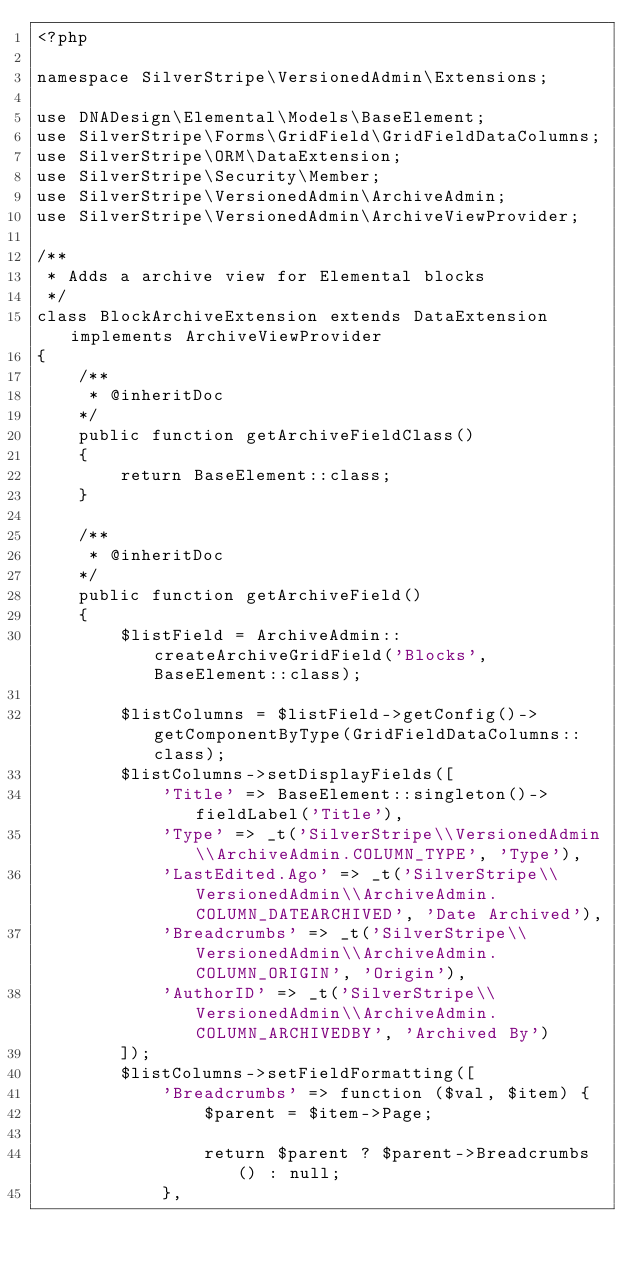Convert code to text. <code><loc_0><loc_0><loc_500><loc_500><_PHP_><?php

namespace SilverStripe\VersionedAdmin\Extensions;

use DNADesign\Elemental\Models\BaseElement;
use SilverStripe\Forms\GridField\GridFieldDataColumns;
use SilverStripe\ORM\DataExtension;
use SilverStripe\Security\Member;
use SilverStripe\VersionedAdmin\ArchiveAdmin;
use SilverStripe\VersionedAdmin\ArchiveViewProvider;

/**
 * Adds a archive view for Elemental blocks
 */
class BlockArchiveExtension extends DataExtension implements ArchiveViewProvider
{
    /**
     * @inheritDoc
    */
    public function getArchiveFieldClass()
    {
        return BaseElement::class;
    }

    /**
     * @inheritDoc
    */
    public function getArchiveField()
    {
        $listField = ArchiveAdmin::createArchiveGridField('Blocks', BaseElement::class);

        $listColumns = $listField->getConfig()->getComponentByType(GridFieldDataColumns::class);
        $listColumns->setDisplayFields([
            'Title' => BaseElement::singleton()->fieldLabel('Title'),
            'Type' => _t('SilverStripe\\VersionedAdmin\\ArchiveAdmin.COLUMN_TYPE', 'Type'),
            'LastEdited.Ago' => _t('SilverStripe\\VersionedAdmin\\ArchiveAdmin.COLUMN_DATEARCHIVED', 'Date Archived'),
            'Breadcrumbs' => _t('SilverStripe\\VersionedAdmin\\ArchiveAdmin.COLUMN_ORIGIN', 'Origin'),
            'AuthorID' => _t('SilverStripe\\VersionedAdmin\\ArchiveAdmin.COLUMN_ARCHIVEDBY', 'Archived By')
        ]);
        $listColumns->setFieldFormatting([
            'Breadcrumbs' => function ($val, $item) {
                $parent = $item->Page;

                return $parent ? $parent->Breadcrumbs() : null;
            },</code> 